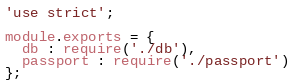<code> <loc_0><loc_0><loc_500><loc_500><_JavaScript_>'use strict';

module.exports = {
  db : require('./db'),
  passport : require('./passport')
};</code> 